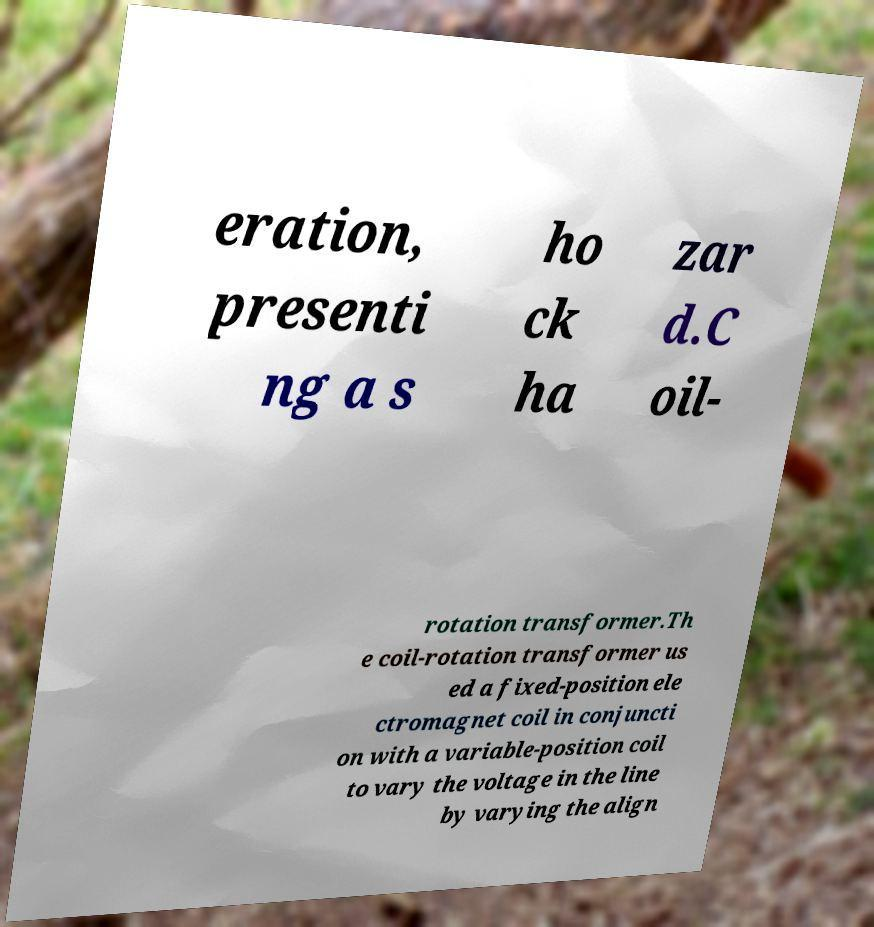There's text embedded in this image that I need extracted. Can you transcribe it verbatim? eration, presenti ng a s ho ck ha zar d.C oil- rotation transformer.Th e coil-rotation transformer us ed a fixed-position ele ctromagnet coil in conjuncti on with a variable-position coil to vary the voltage in the line by varying the align 